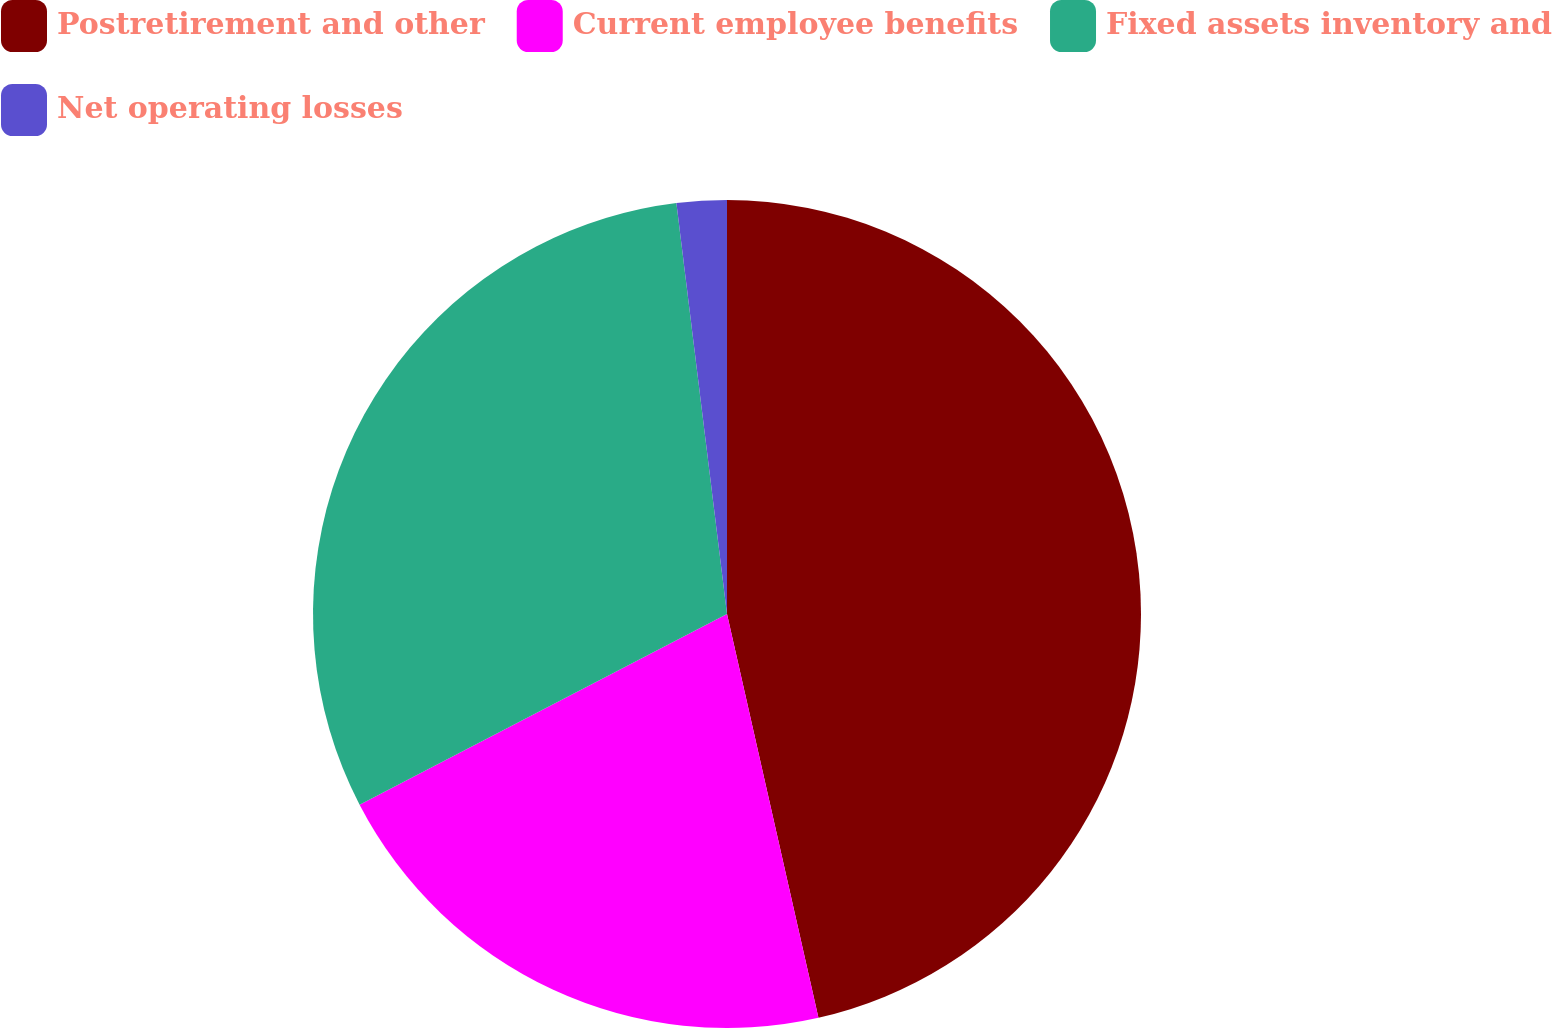Convert chart to OTSL. <chart><loc_0><loc_0><loc_500><loc_500><pie_chart><fcel>Postretirement and other<fcel>Current employee benefits<fcel>Fixed assets inventory and<fcel>Net operating losses<nl><fcel>46.45%<fcel>20.92%<fcel>30.67%<fcel>1.95%<nl></chart> 